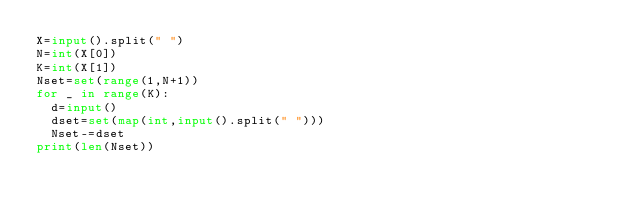Convert code to text. <code><loc_0><loc_0><loc_500><loc_500><_Python_>X=input().split(" ")
N=int(X[0])
K=int(X[1])
Nset=set(range(1,N+1))
for _ in range(K):
  d=input()
  dset=set(map(int,input().split(" ")))
  Nset-=dset
print(len(Nset))</code> 